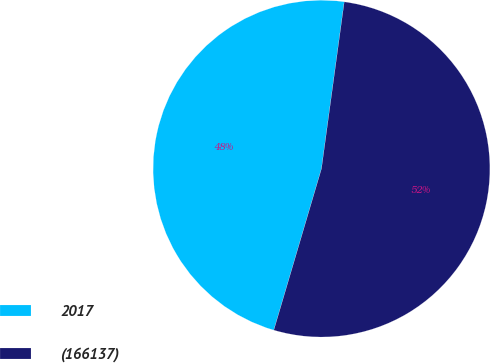<chart> <loc_0><loc_0><loc_500><loc_500><pie_chart><fcel>2017<fcel>(166137)<nl><fcel>47.59%<fcel>52.41%<nl></chart> 